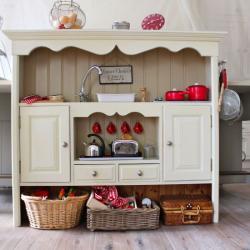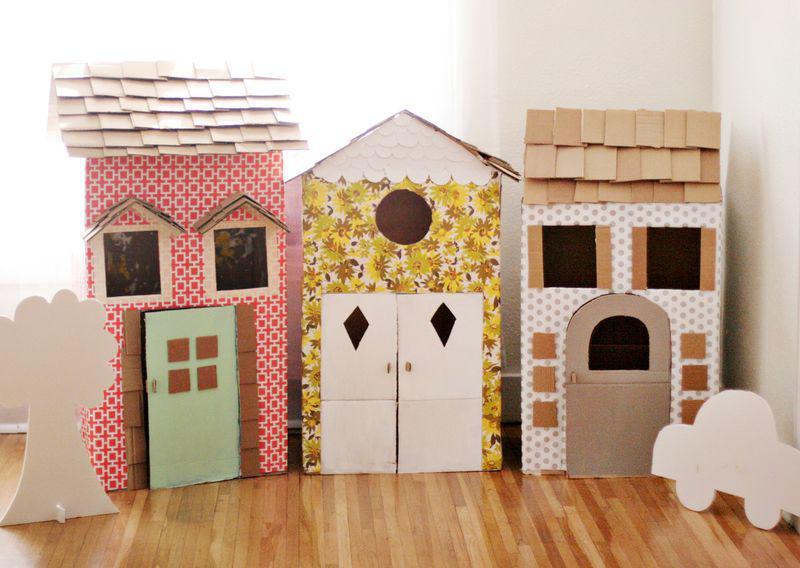The first image is the image on the left, the second image is the image on the right. Examine the images to the left and right. Is the description "One of the images shows a cardboard boat and another image shows a cardboard building." accurate? Answer yes or no. No. The first image is the image on the left, the second image is the image on the right. Analyze the images presented: Is the assertion "The right image features at least one child inside a long boat made out of joined cardboard boxes." valid? Answer yes or no. No. 